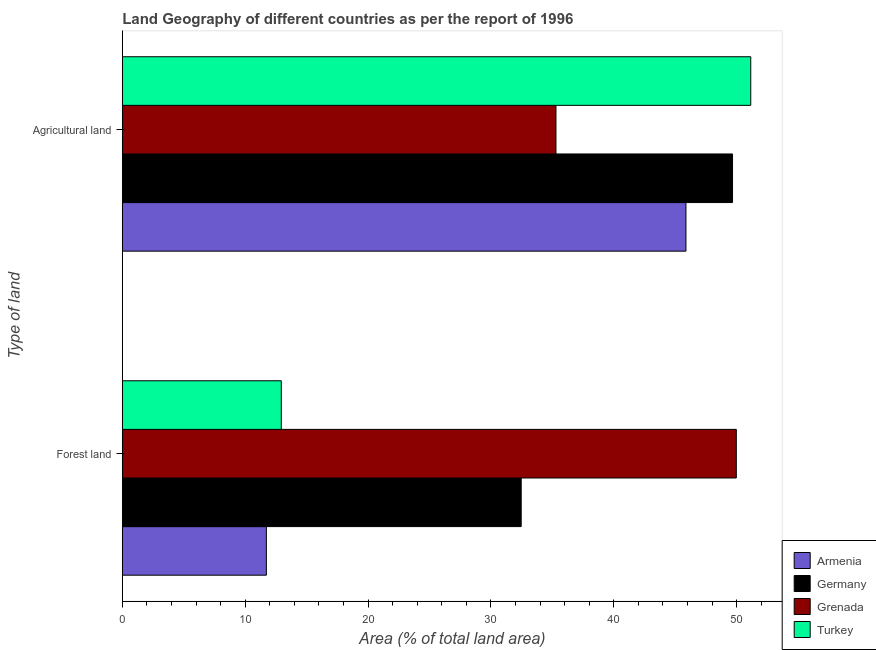How many groups of bars are there?
Your answer should be compact. 2. How many bars are there on the 1st tick from the bottom?
Keep it short and to the point. 4. What is the label of the 2nd group of bars from the top?
Your response must be concise. Forest land. What is the percentage of land area under forests in Grenada?
Provide a short and direct response. 49.97. Across all countries, what is the maximum percentage of land area under agriculture?
Provide a short and direct response. 51.15. Across all countries, what is the minimum percentage of land area under forests?
Your answer should be very brief. 11.72. In which country was the percentage of land area under agriculture maximum?
Provide a succinct answer. Turkey. In which country was the percentage of land area under agriculture minimum?
Ensure brevity in your answer.  Grenada. What is the total percentage of land area under agriculture in the graph?
Provide a short and direct response. 181.98. What is the difference between the percentage of land area under agriculture in Grenada and that in Germany?
Keep it short and to the point. -14.37. What is the difference between the percentage of land area under agriculture in Turkey and the percentage of land area under forests in Armenia?
Offer a terse response. 39.42. What is the average percentage of land area under forests per country?
Offer a very short reply. 26.77. What is the difference between the percentage of land area under agriculture and percentage of land area under forests in Germany?
Provide a short and direct response. 17.2. In how many countries, is the percentage of land area under forests greater than 40 %?
Your answer should be very brief. 1. What is the ratio of the percentage of land area under agriculture in Turkey to that in Germany?
Your answer should be very brief. 1.03. In how many countries, is the percentage of land area under forests greater than the average percentage of land area under forests taken over all countries?
Your answer should be very brief. 2. What does the 1st bar from the bottom in Forest land represents?
Your answer should be very brief. Armenia. Are all the bars in the graph horizontal?
Provide a succinct answer. Yes. How many countries are there in the graph?
Provide a succinct answer. 4. How are the legend labels stacked?
Offer a very short reply. Vertical. What is the title of the graph?
Your response must be concise. Land Geography of different countries as per the report of 1996. What is the label or title of the X-axis?
Your response must be concise. Area (% of total land area). What is the label or title of the Y-axis?
Give a very brief answer. Type of land. What is the Area (% of total land area) of Armenia in Forest land?
Keep it short and to the point. 11.72. What is the Area (% of total land area) of Germany in Forest land?
Offer a terse response. 32.46. What is the Area (% of total land area) of Grenada in Forest land?
Your answer should be very brief. 49.97. What is the Area (% of total land area) of Turkey in Forest land?
Offer a very short reply. 12.94. What is the Area (% of total land area) of Armenia in Agricultural land?
Offer a very short reply. 45.87. What is the Area (% of total land area) in Germany in Agricultural land?
Give a very brief answer. 49.66. What is the Area (% of total land area) in Grenada in Agricultural land?
Offer a very short reply. 35.29. What is the Area (% of total land area) in Turkey in Agricultural land?
Ensure brevity in your answer.  51.15. Across all Type of land, what is the maximum Area (% of total land area) of Armenia?
Offer a terse response. 45.87. Across all Type of land, what is the maximum Area (% of total land area) in Germany?
Make the answer very short. 49.66. Across all Type of land, what is the maximum Area (% of total land area) of Grenada?
Offer a very short reply. 49.97. Across all Type of land, what is the maximum Area (% of total land area) in Turkey?
Give a very brief answer. 51.15. Across all Type of land, what is the minimum Area (% of total land area) of Armenia?
Keep it short and to the point. 11.72. Across all Type of land, what is the minimum Area (% of total land area) in Germany?
Provide a succinct answer. 32.46. Across all Type of land, what is the minimum Area (% of total land area) in Grenada?
Provide a succinct answer. 35.29. Across all Type of land, what is the minimum Area (% of total land area) of Turkey?
Give a very brief answer. 12.94. What is the total Area (% of total land area) in Armenia in the graph?
Make the answer very short. 57.6. What is the total Area (% of total land area) of Germany in the graph?
Your answer should be very brief. 82.13. What is the total Area (% of total land area) of Grenada in the graph?
Provide a succinct answer. 85.26. What is the total Area (% of total land area) in Turkey in the graph?
Your answer should be compact. 64.09. What is the difference between the Area (% of total land area) in Armenia in Forest land and that in Agricultural land?
Keep it short and to the point. -34.15. What is the difference between the Area (% of total land area) of Germany in Forest land and that in Agricultural land?
Provide a short and direct response. -17.2. What is the difference between the Area (% of total land area) of Grenada in Forest land and that in Agricultural land?
Ensure brevity in your answer.  14.68. What is the difference between the Area (% of total land area) in Turkey in Forest land and that in Agricultural land?
Provide a succinct answer. -38.21. What is the difference between the Area (% of total land area) in Armenia in Forest land and the Area (% of total land area) in Germany in Agricultural land?
Offer a terse response. -37.94. What is the difference between the Area (% of total land area) in Armenia in Forest land and the Area (% of total land area) in Grenada in Agricultural land?
Keep it short and to the point. -23.57. What is the difference between the Area (% of total land area) in Armenia in Forest land and the Area (% of total land area) in Turkey in Agricultural land?
Offer a terse response. -39.42. What is the difference between the Area (% of total land area) in Germany in Forest land and the Area (% of total land area) in Grenada in Agricultural land?
Your answer should be very brief. -2.83. What is the difference between the Area (% of total land area) in Germany in Forest land and the Area (% of total land area) in Turkey in Agricultural land?
Your answer should be compact. -18.68. What is the difference between the Area (% of total land area) of Grenada in Forest land and the Area (% of total land area) of Turkey in Agricultural land?
Provide a succinct answer. -1.18. What is the average Area (% of total land area) of Armenia per Type of land?
Your answer should be very brief. 28.8. What is the average Area (% of total land area) of Germany per Type of land?
Your response must be concise. 41.06. What is the average Area (% of total land area) in Grenada per Type of land?
Provide a short and direct response. 42.63. What is the average Area (% of total land area) in Turkey per Type of land?
Make the answer very short. 32.04. What is the difference between the Area (% of total land area) in Armenia and Area (% of total land area) in Germany in Forest land?
Ensure brevity in your answer.  -20.74. What is the difference between the Area (% of total land area) of Armenia and Area (% of total land area) of Grenada in Forest land?
Give a very brief answer. -38.25. What is the difference between the Area (% of total land area) of Armenia and Area (% of total land area) of Turkey in Forest land?
Your answer should be compact. -1.21. What is the difference between the Area (% of total land area) in Germany and Area (% of total land area) in Grenada in Forest land?
Your answer should be compact. -17.51. What is the difference between the Area (% of total land area) of Germany and Area (% of total land area) of Turkey in Forest land?
Offer a very short reply. 19.52. What is the difference between the Area (% of total land area) of Grenada and Area (% of total land area) of Turkey in Forest land?
Offer a terse response. 37.03. What is the difference between the Area (% of total land area) of Armenia and Area (% of total land area) of Germany in Agricultural land?
Keep it short and to the point. -3.79. What is the difference between the Area (% of total land area) in Armenia and Area (% of total land area) in Grenada in Agricultural land?
Offer a very short reply. 10.58. What is the difference between the Area (% of total land area) in Armenia and Area (% of total land area) in Turkey in Agricultural land?
Provide a short and direct response. -5.27. What is the difference between the Area (% of total land area) of Germany and Area (% of total land area) of Grenada in Agricultural land?
Offer a terse response. 14.37. What is the difference between the Area (% of total land area) in Germany and Area (% of total land area) in Turkey in Agricultural land?
Ensure brevity in your answer.  -1.48. What is the difference between the Area (% of total land area) of Grenada and Area (% of total land area) of Turkey in Agricultural land?
Your answer should be compact. -15.85. What is the ratio of the Area (% of total land area) of Armenia in Forest land to that in Agricultural land?
Provide a succinct answer. 0.26. What is the ratio of the Area (% of total land area) in Germany in Forest land to that in Agricultural land?
Keep it short and to the point. 0.65. What is the ratio of the Area (% of total land area) of Grenada in Forest land to that in Agricultural land?
Give a very brief answer. 1.42. What is the ratio of the Area (% of total land area) in Turkey in Forest land to that in Agricultural land?
Make the answer very short. 0.25. What is the difference between the highest and the second highest Area (% of total land area) of Armenia?
Give a very brief answer. 34.15. What is the difference between the highest and the second highest Area (% of total land area) in Germany?
Your answer should be very brief. 17.2. What is the difference between the highest and the second highest Area (% of total land area) in Grenada?
Provide a succinct answer. 14.68. What is the difference between the highest and the second highest Area (% of total land area) in Turkey?
Your answer should be compact. 38.21. What is the difference between the highest and the lowest Area (% of total land area) in Armenia?
Your answer should be compact. 34.15. What is the difference between the highest and the lowest Area (% of total land area) in Germany?
Offer a terse response. 17.2. What is the difference between the highest and the lowest Area (% of total land area) in Grenada?
Your answer should be very brief. 14.68. What is the difference between the highest and the lowest Area (% of total land area) of Turkey?
Give a very brief answer. 38.21. 